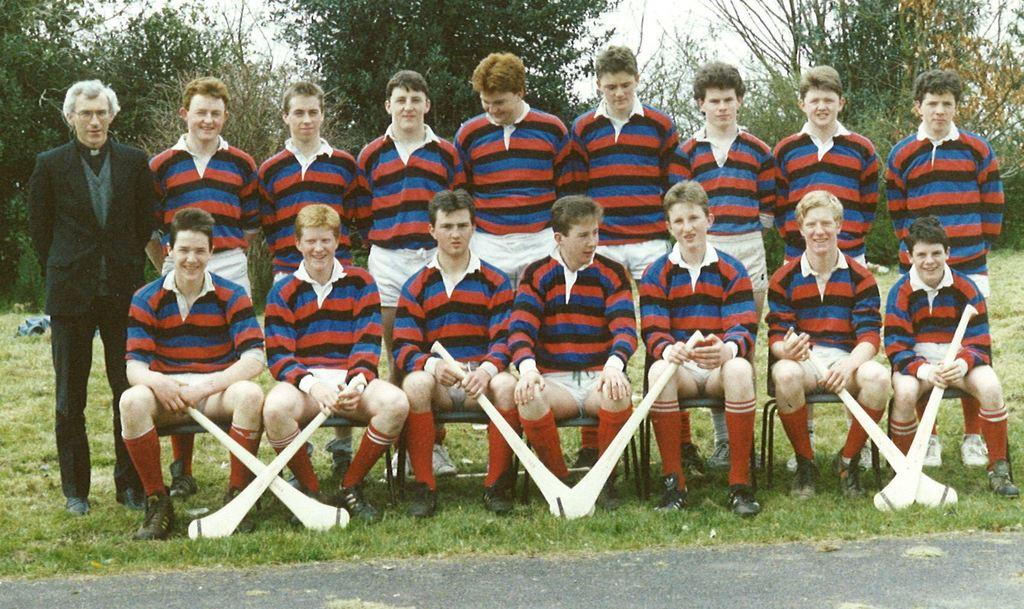What is the main subject of the image? The main subject of the image is a group of people. How are the people arranged in the image? Eight people are sitting on chairs, and nine people are standing. What type of environment is depicted in the image? There is grass, trees, and the sky visible in the image, suggesting an outdoor setting. Can you tell me how many crows are sitting on the chairs in the image? There are no crows present in the image; it features a group of people sitting on chairs and standing. What type of motion is being performed by the people in the image? The image does not depict any specific motion; it simply shows people sitting and standing. 